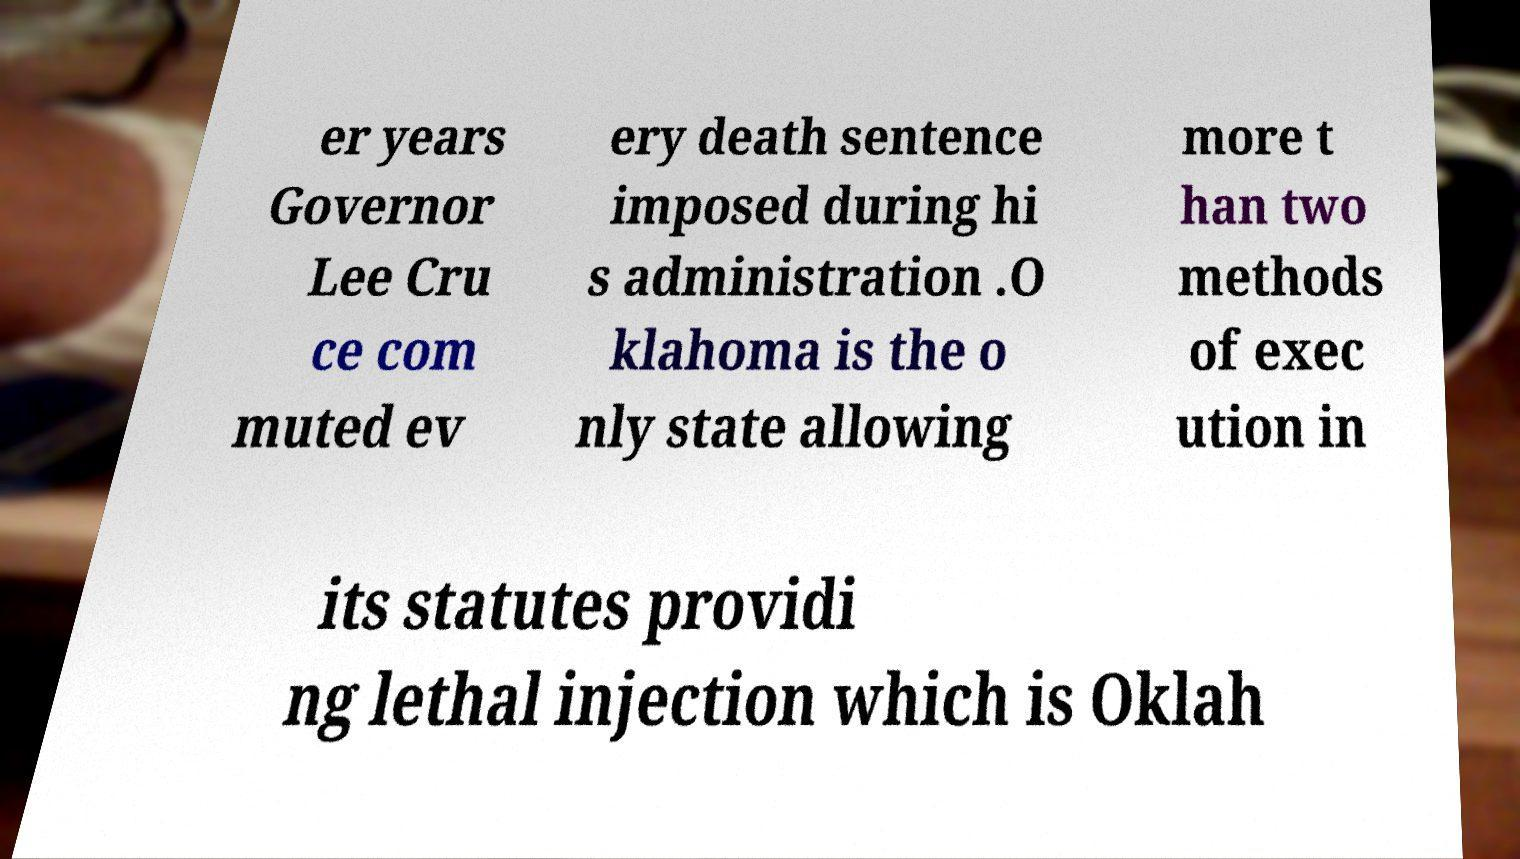Please read and relay the text visible in this image. What does it say? er years Governor Lee Cru ce com muted ev ery death sentence imposed during hi s administration .O klahoma is the o nly state allowing more t han two methods of exec ution in its statutes providi ng lethal injection which is Oklah 